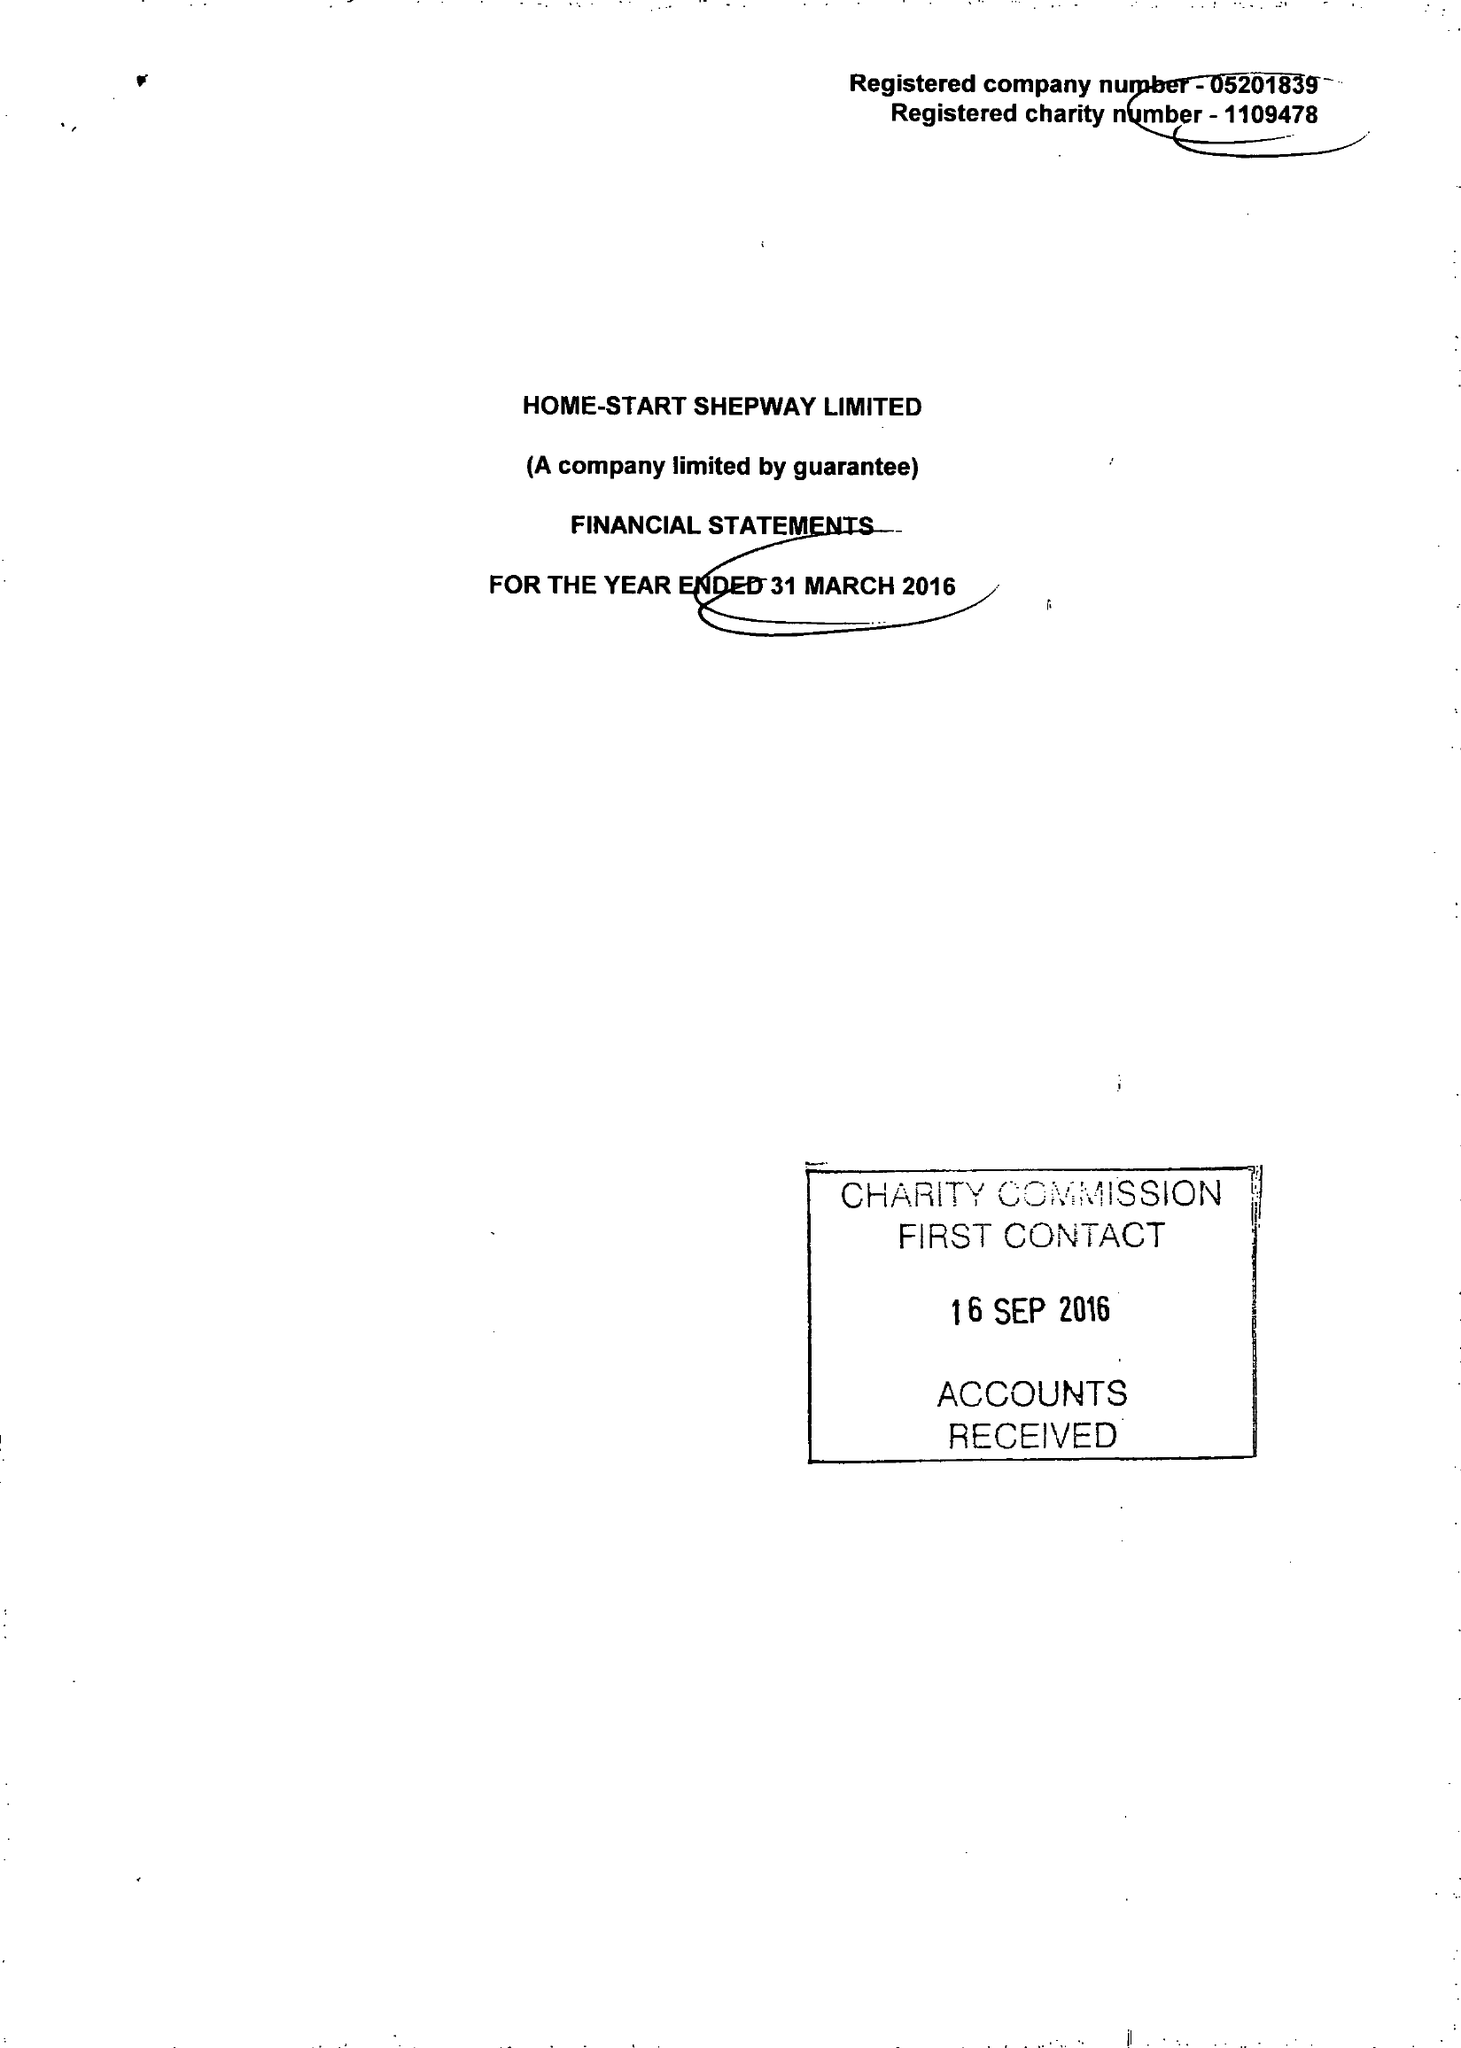What is the value for the income_annually_in_british_pounds?
Answer the question using a single word or phrase. 333000.00 